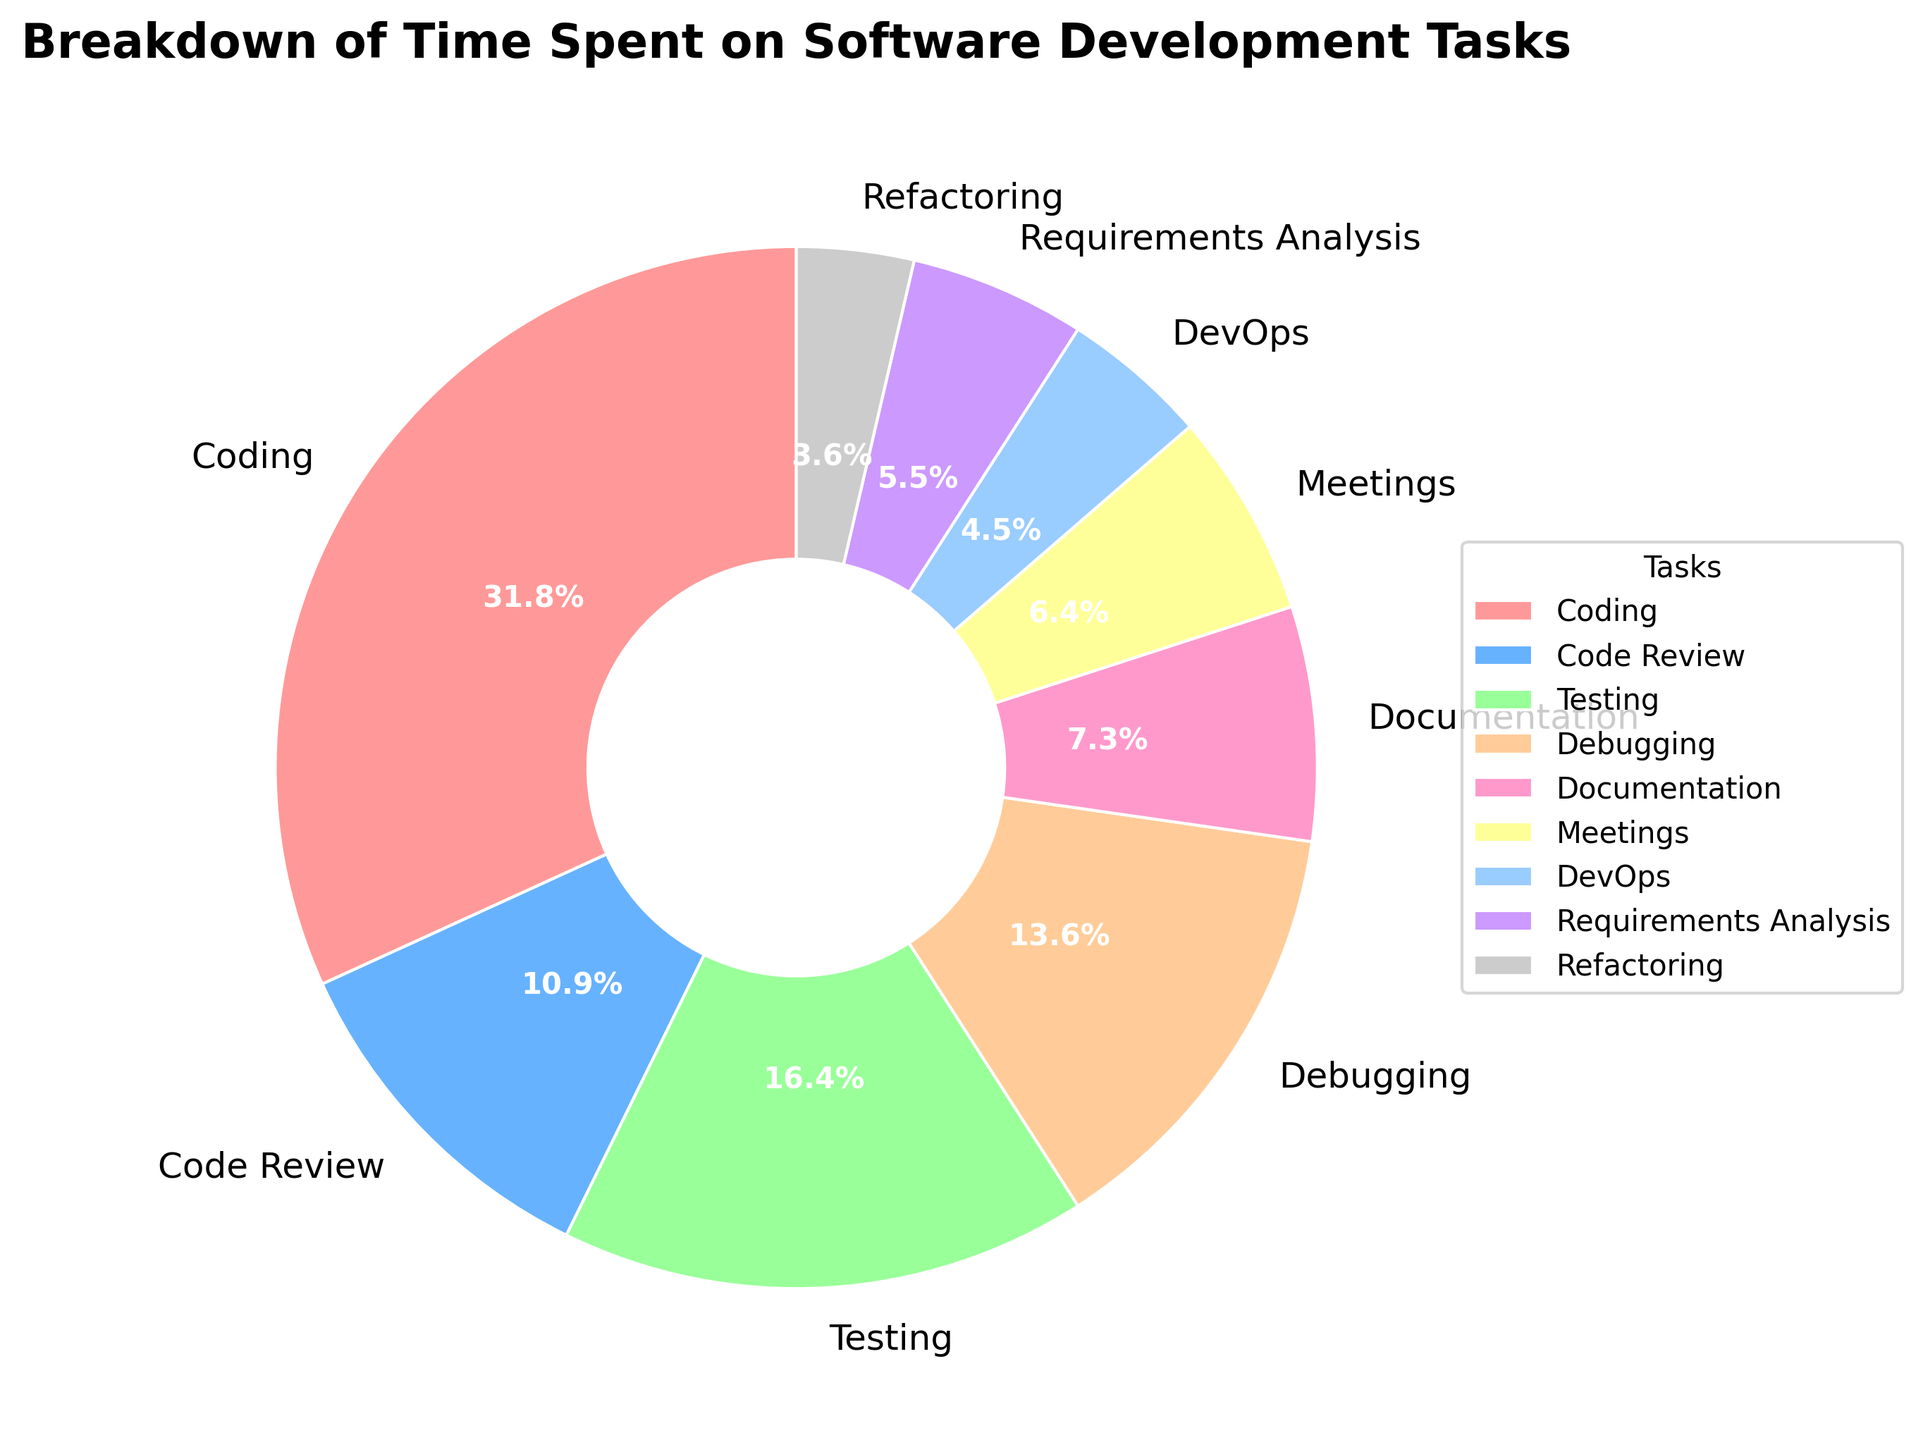what task takes up the largest percentage of time? By looking at the pie chart, the task with the largest wedge will indicate the highest percentage. Coding takes up the largest section of the pie chart with 35%.
Answer: Coding Which task takes up less time: Documentation or Requirements Analysis? We need to identify the sections for Documentation and Requirements Analysis. Documentation covers 8% while Requirements Analysis covers 6%. Since 8% is greater than 6%, Requirements Analysis takes up less time.
Answer: Requirements Analysis What is the total percentage of time spent on Testing and Debugging together? We will add the percentages for Testing and Debugging. Testing is 18% and Debugging is 15%. Therefore, 18% + 15% = 33%.
Answer: 33% Which tasks take up less than 10% of the time each? We look for the sections with percentages less than 10%. These are Documentation (8%), Meetings (7%), DevOps (5%), Requirements Analysis (6%), and Refactoring (4%).
Answer: Documentation, Meetings, DevOps, Requirements Analysis, Refactoring How many more percentage points is spent on Coding compared to Meetings? Identify how much time is spent on Coding and Meetings. Coding takes 35% while Meetings take 7%. The difference is 35% - 7% = 28%.
Answer: 28% Which task takes up the smallest percentage of time and what is it? By examining the pie chart, the smallest wedge represents the smallest percentage which is Refactoring at 4%.
Answer: Refactoring Is the time spent on Code Review higher or lower than that spent on DevOps? By examining the chart, we see that Code Review is 12% while DevOps is 5%. Since 12% is higher than 5%, the time on Code Review is higher.
Answer: Higher What are the total combined percentage points of all tasks taking up more than 10% of the time? Identify all tasks with percentages greater than 10% which are Coding (35%), Code Review (12%), Testing (18%), and Debugging (15%). Add them together: 35 + 12 + 18 + 15 = 80%.
Answer: 80% Which two tasks together make up roughly 25% of the total time? By examining the chart, we need the combination of tasks summing to 25%. Meetings (7%) and Testing (18%) add up to 25%.
Answer: Meetings and Testing 